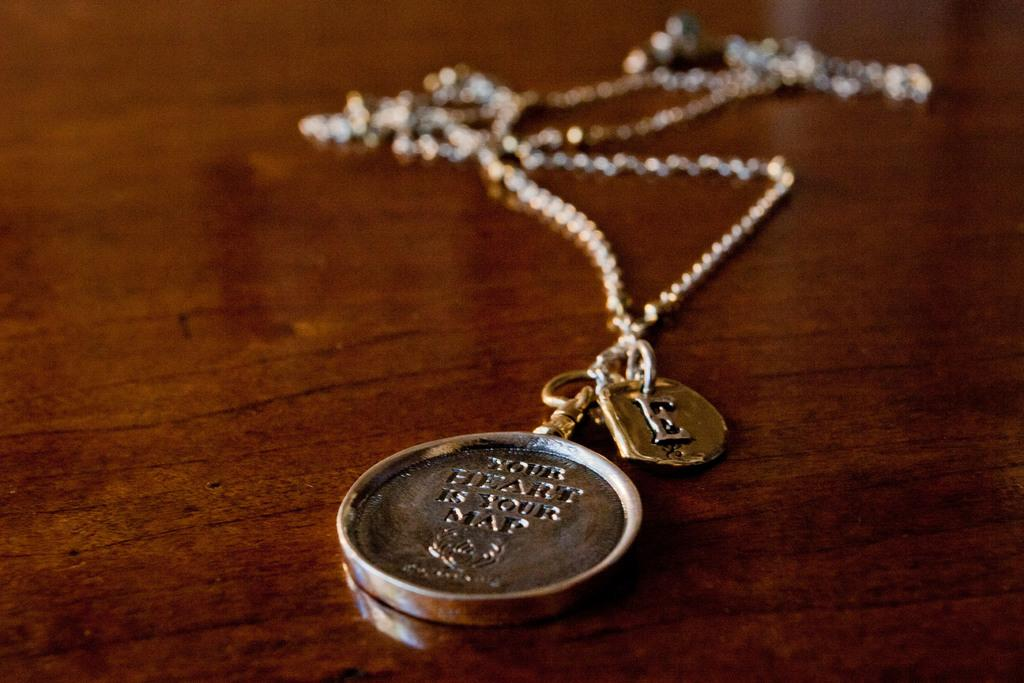<image>
Share a concise interpretation of the image provided. A pendant saying your heart is your map is on a table. 